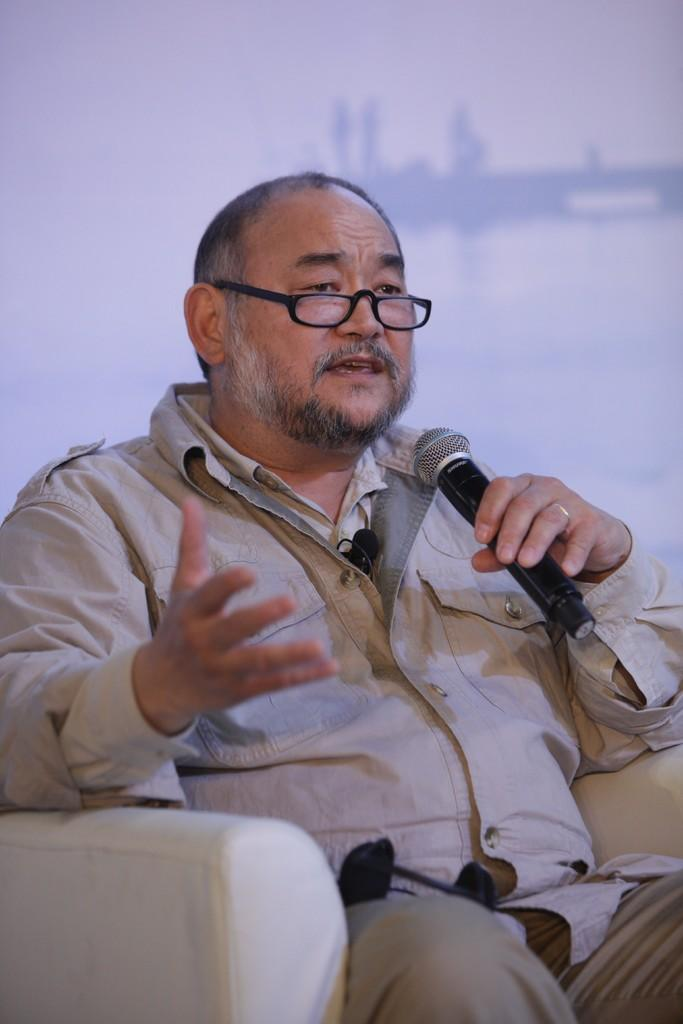What is the man in the image doing? The man is sitting in the image. What is the man wearing? The man is wearing clothes, spectacles, and a finger ring. What object is the man holding in his hand? The man is holding a microphone in his hand. How would you describe the background of the image? The background of the image is blurred. How many clocks are visible in the image? There are no clocks visible in the image. What type of account does the man have with the bank in the image? There is no mention of a bank or an account in the image. 